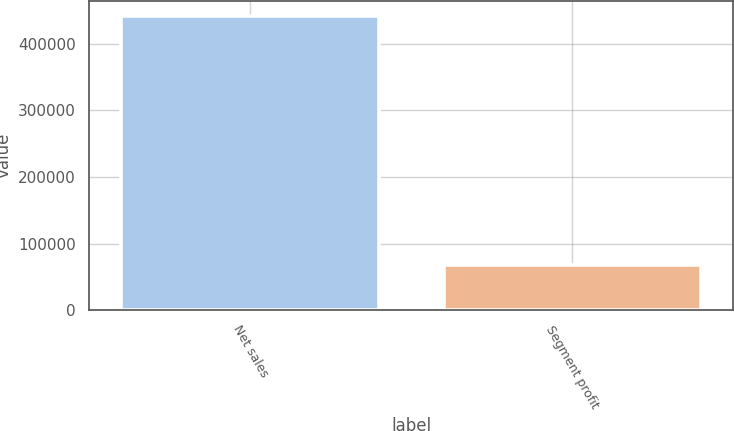Convert chart to OTSL. <chart><loc_0><loc_0><loc_500><loc_500><bar_chart><fcel>Net sales<fcel>Segment profit<nl><fcel>441707<fcel>67901<nl></chart> 